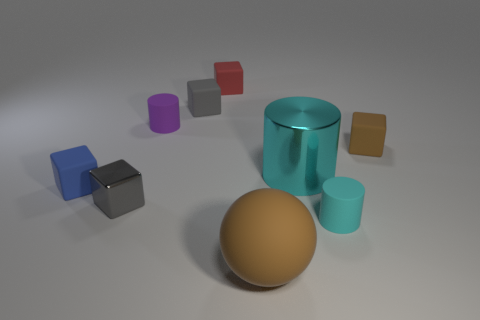Subtract all red blocks. How many blocks are left? 4 Subtract all tiny brown cubes. How many cubes are left? 4 Subtract all brown blocks. Subtract all brown cylinders. How many blocks are left? 4 Subtract all cubes. How many objects are left? 4 Subtract 1 brown balls. How many objects are left? 8 Subtract all purple cylinders. Subtract all small objects. How many objects are left? 1 Add 2 big cyan cylinders. How many big cyan cylinders are left? 3 Add 8 large rubber things. How many large rubber things exist? 9 